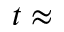<formula> <loc_0><loc_0><loc_500><loc_500>t \approx</formula> 